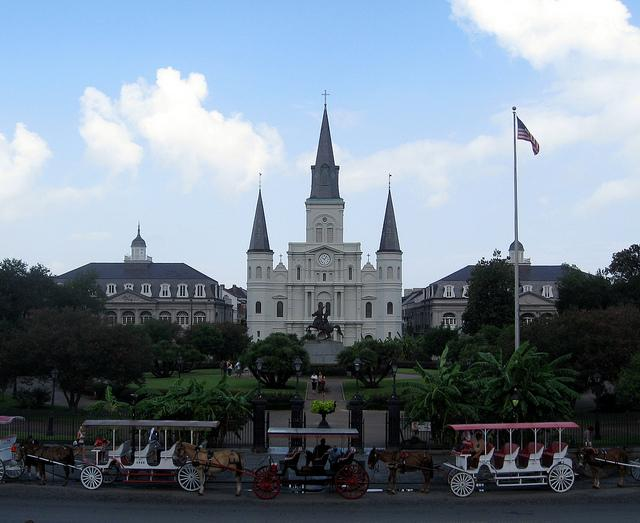What period of the day is it in the photo? late afternoon 